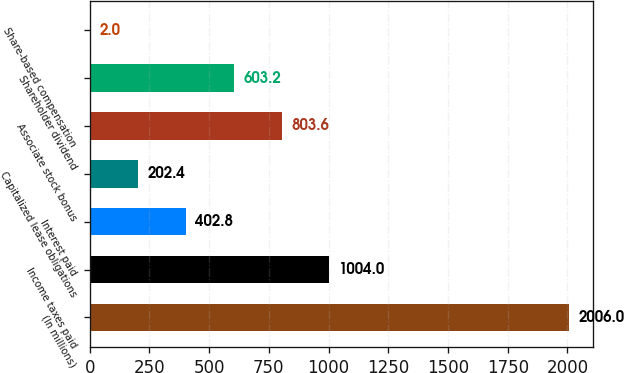Convert chart. <chart><loc_0><loc_0><loc_500><loc_500><bar_chart><fcel>(In millions)<fcel>Income taxes paid<fcel>Interest paid<fcel>Capitalized lease obligations<fcel>Associate stock bonus<fcel>Shareholder dividend<fcel>Share-based compensation<nl><fcel>2006<fcel>1004<fcel>402.8<fcel>202.4<fcel>803.6<fcel>603.2<fcel>2<nl></chart> 